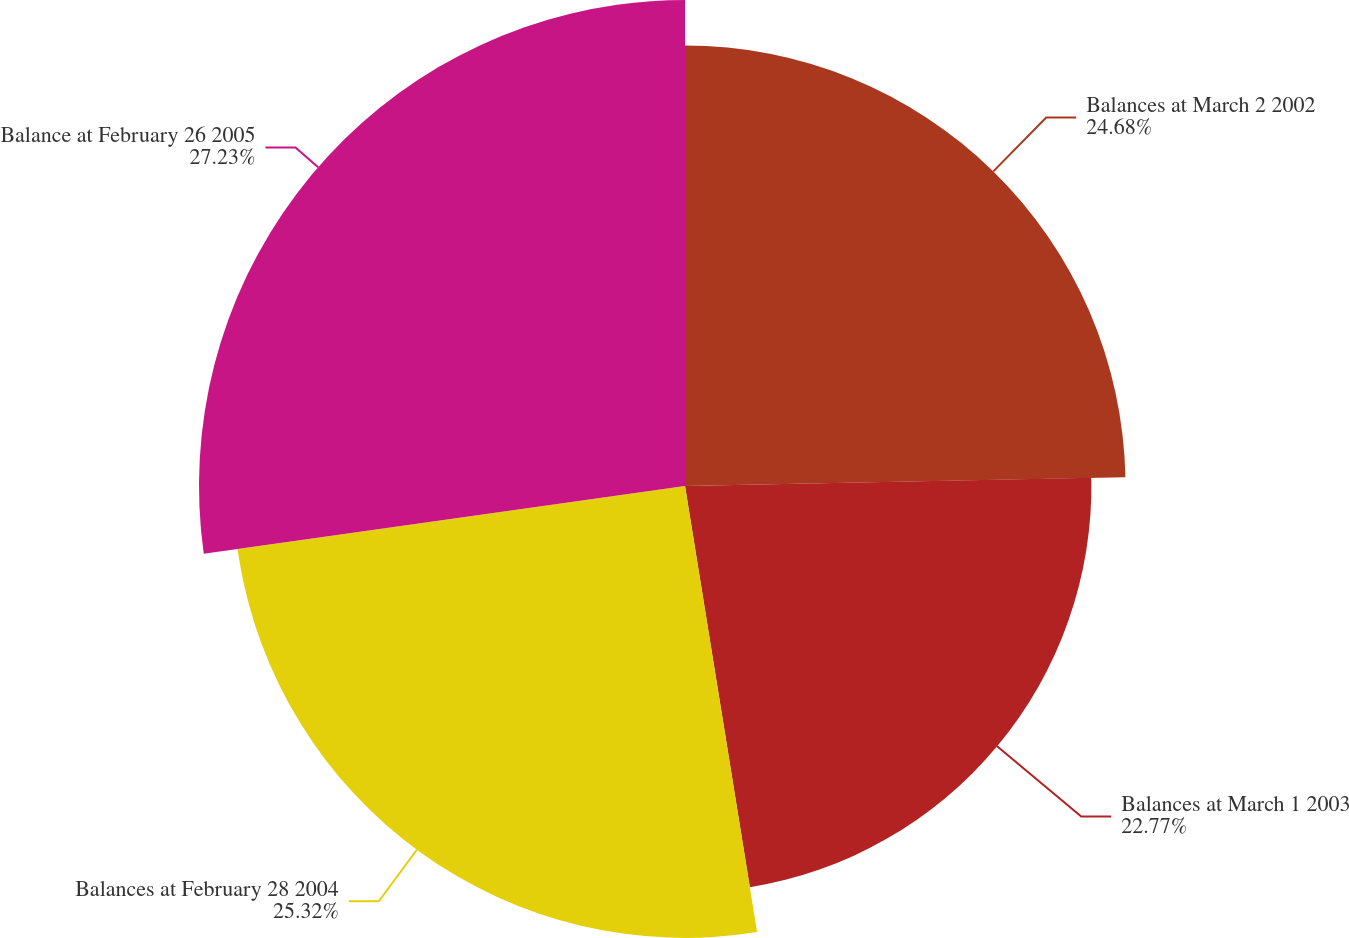<chart> <loc_0><loc_0><loc_500><loc_500><pie_chart><fcel>Balances at March 2 2002<fcel>Balances at March 1 2003<fcel>Balances at February 28 2004<fcel>Balance at February 26 2005<nl><fcel>24.68%<fcel>22.77%<fcel>25.32%<fcel>27.23%<nl></chart> 